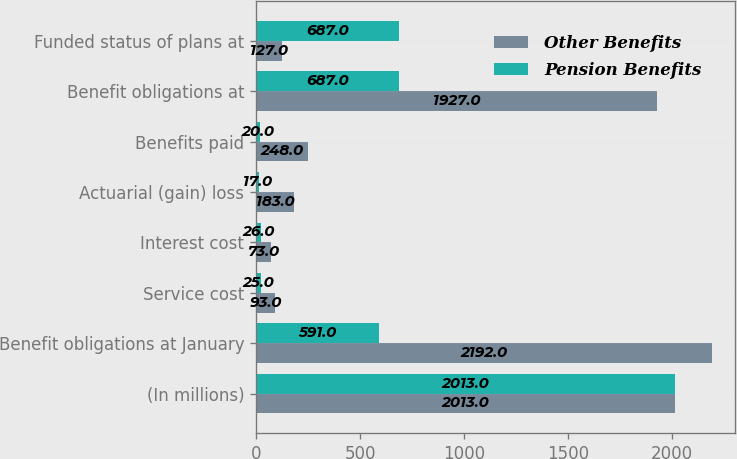<chart> <loc_0><loc_0><loc_500><loc_500><stacked_bar_chart><ecel><fcel>(In millions)<fcel>Benefit obligations at January<fcel>Service cost<fcel>Interest cost<fcel>Actuarial (gain) loss<fcel>Benefits paid<fcel>Benefit obligations at<fcel>Funded status of plans at<nl><fcel>Other Benefits<fcel>2013<fcel>2192<fcel>93<fcel>73<fcel>183<fcel>248<fcel>1927<fcel>127<nl><fcel>Pension Benefits<fcel>2013<fcel>591<fcel>25<fcel>26<fcel>17<fcel>20<fcel>687<fcel>687<nl></chart> 